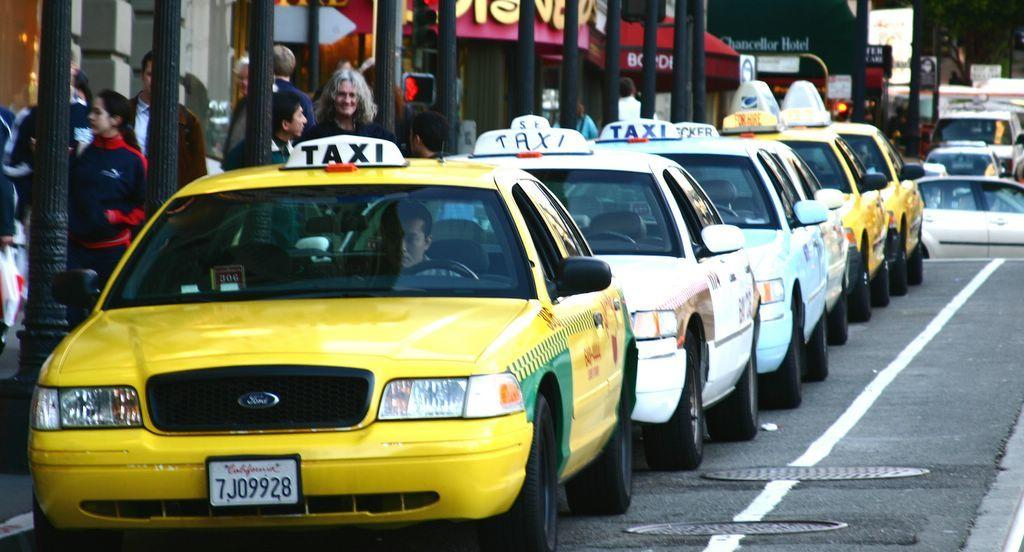<image>
Share a concise interpretation of the image provided. A row of taxis with a California tag 7J09928 on the front car. 